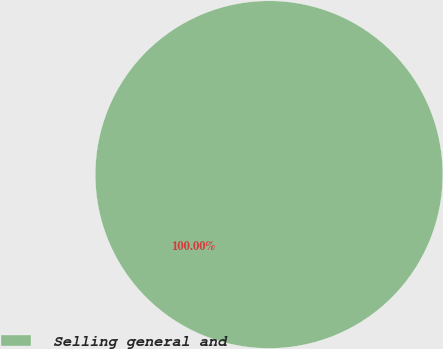<chart> <loc_0><loc_0><loc_500><loc_500><pie_chart><fcel>Selling general and<nl><fcel>100.0%<nl></chart> 